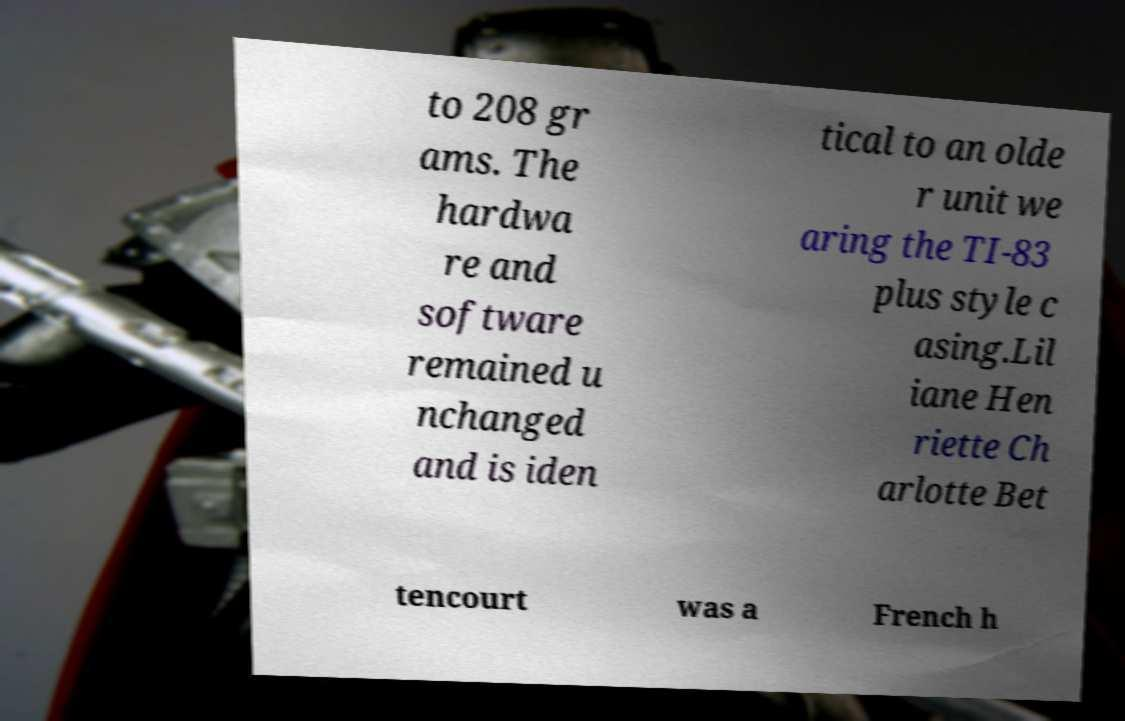Please identify and transcribe the text found in this image. to 208 gr ams. The hardwa re and software remained u nchanged and is iden tical to an olde r unit we aring the TI-83 plus style c asing.Lil iane Hen riette Ch arlotte Bet tencourt was a French h 